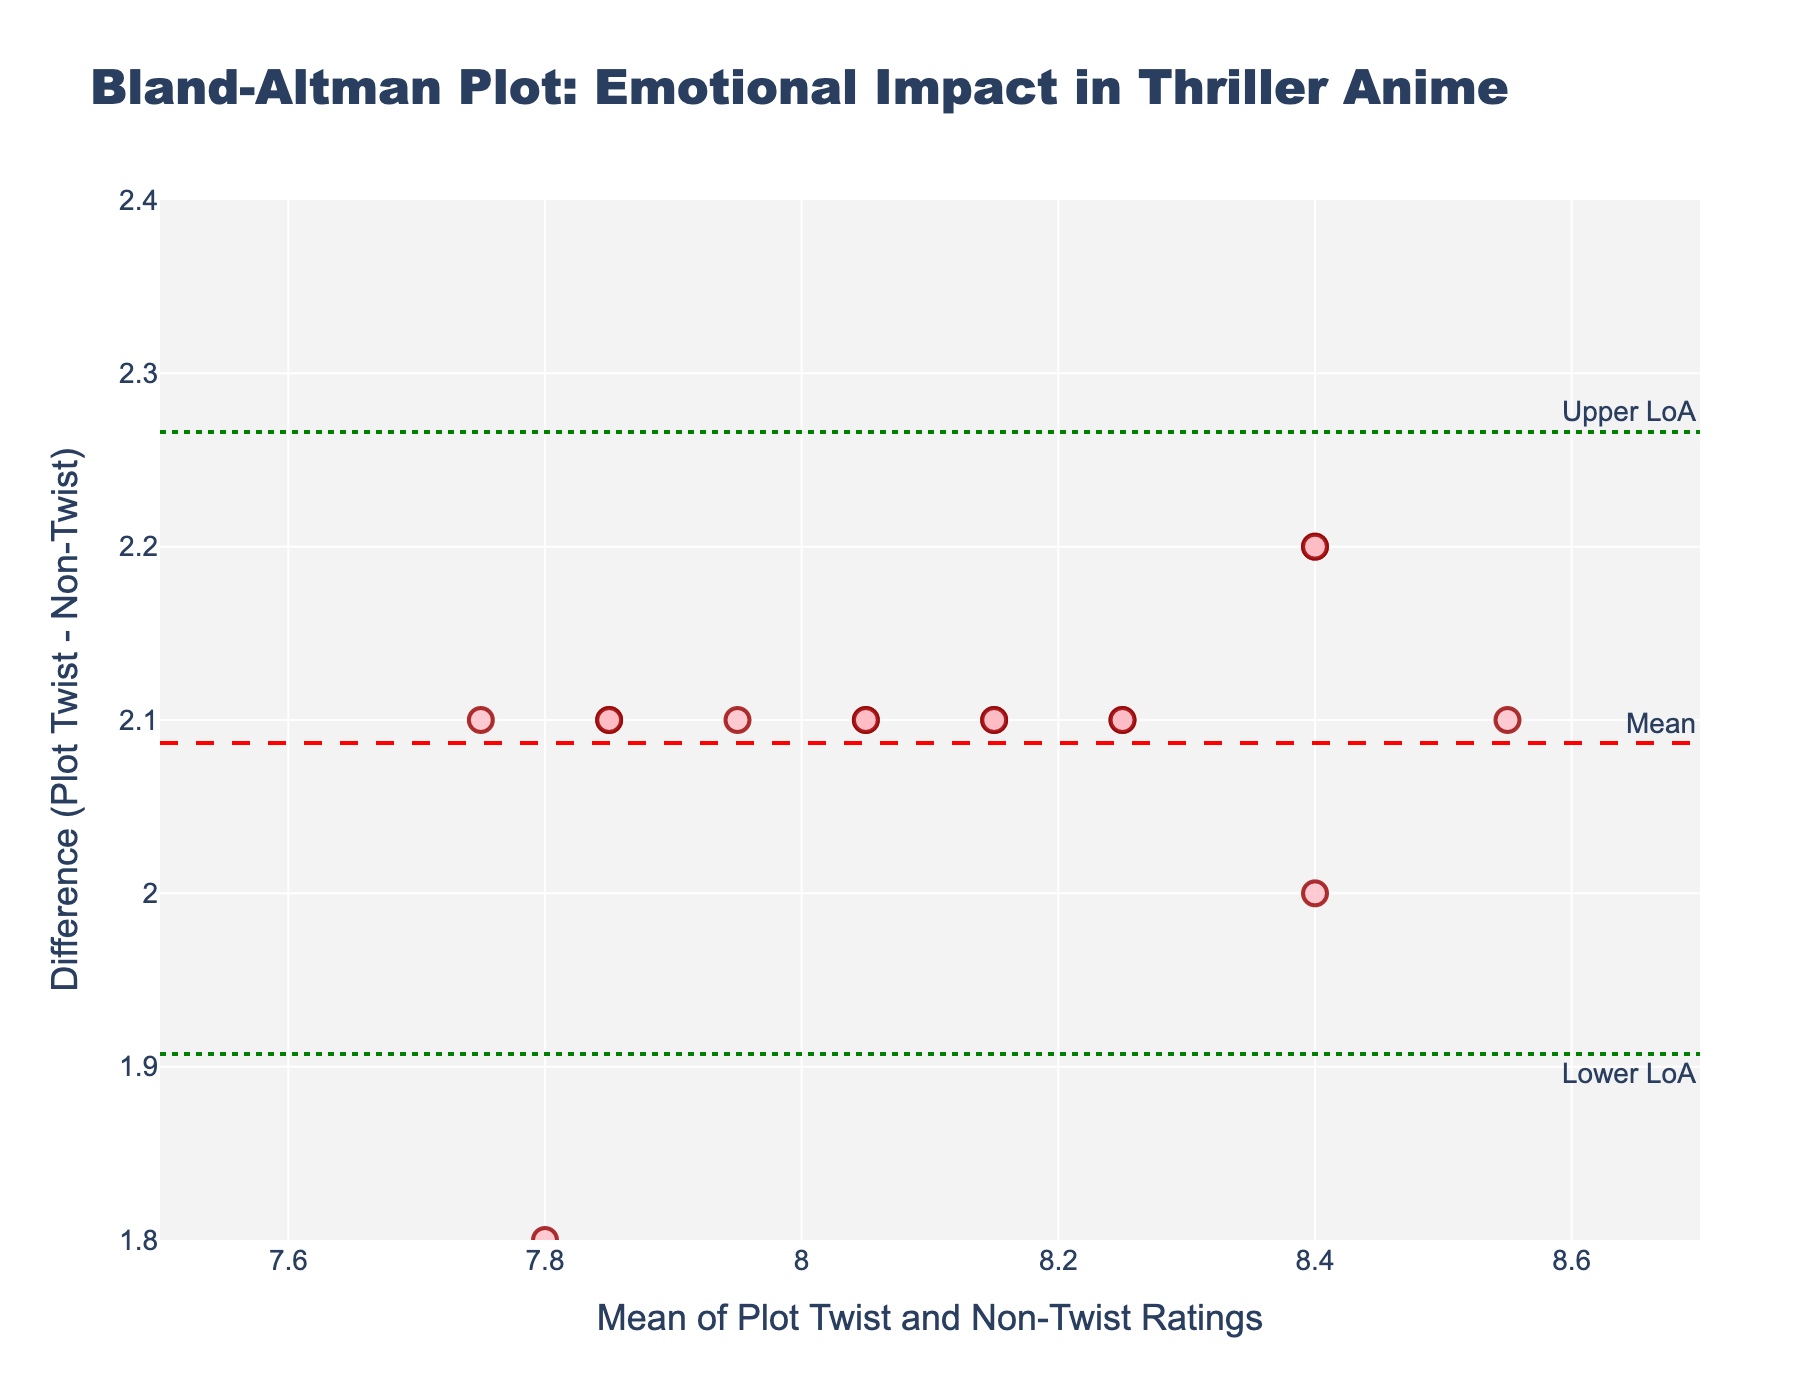What is the title of the plot? The title is located at the top center of the plot in large font. It reads, "Bland-Altman Plot: Emotional Impact in Thriller Anime."
Answer: Bland-Altman Plot: Emotional Impact in Thriller Anime How many data points are displayed on the plot? The plot shows several markers representing the data points. Each marker corresponds to a pair of ratings from plot twist moments and non-twist scenes with its difference plotted on the y-axis and average plotted on the x-axis. By counting the markers, we find there are 15 data points.
Answer: 15 What is the y-axis label? The y-axis label is displayed vertically along the left side of the plot. It reads "Difference (Plot Twist - Non-Twist)."
Answer: Difference (Plot Twist - Non-Twist) What is the mean difference between plot twist moments and non-twist scenes? The mean difference is represented by a horizontal dashed red line on the plot. The label near the line reads "Mean." The mean difference is clearly marked at around 2.1 on the y-axis.
Answer: 2.1 What are the upper and lower limits of agreement on this plot? The upper and lower limits of agreement are shown as horizontal dotted green lines. These lines are annotated "Upper LoA" and "Lower LoA," which denote the limits. The upper limit is around 2.4, and the lower limit is about 1.8.
Answer: 2.4 (upper), 1.8 (lower) Which marker (if any) lies closest to the mean difference line? By observing the plot, it's evident that among the 15 markers, several markers lie close to the mean difference line. Specifically, the marker approximately at (8.15, 2.1) is the closest to the dashed red line indicating the mean difference.
Answer: Marker at (8.15, 2.1) How many data points lie within the limits of agreement? To find this, count the markers that lie between the upper limit (2.4) and lower limit (1.8). Observing the plot, all 15 data points lie within these limits.
Answer: 15 Is there any data point that deviates significantly from the mean difference line? To determine if any data point is a significant outlier, look for markers far from the mean difference line (2.1). In this plot, all markers hover relatively close to the mean difference, with none deviating significantly outside the range provided by the upper and lower limits of agreement.
Answer: No What does the horizontal line labeled "Upper LoA" represent? The "Upper LoA" line indicates the upper limit of agreement, calculated as the mean difference plus 1.96 times the standard deviation of the differences. It shows the upper boundary where most differences are expected to lie, given the data's normal distribution.
Answer: Upper limit of agreement What is the significance of the dotted green lines in the plot? The dotted green lines represent the limits of agreement. These lines show the range within which most differences between plot twist moments and non-twist scenes should fall. Mathematically, they are calculated as the mean difference plus and minus 1.96 times the standard deviation of the differences.
Answer: Limits of agreement 